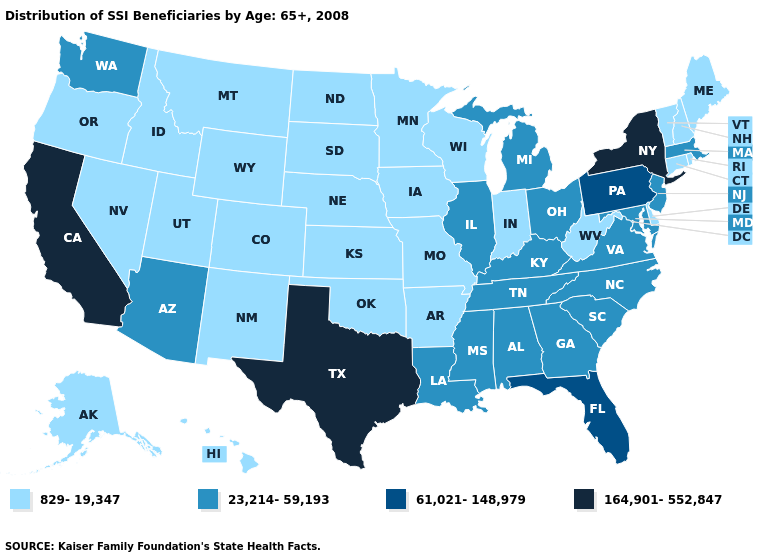What is the lowest value in the USA?
Write a very short answer. 829-19,347. Name the states that have a value in the range 23,214-59,193?
Answer briefly. Alabama, Arizona, Georgia, Illinois, Kentucky, Louisiana, Maryland, Massachusetts, Michigan, Mississippi, New Jersey, North Carolina, Ohio, South Carolina, Tennessee, Virginia, Washington. What is the value of Alabama?
Be succinct. 23,214-59,193. Does Kentucky have a higher value than Maryland?
Short answer required. No. Among the states that border New Jersey , does New York have the highest value?
Give a very brief answer. Yes. Which states have the lowest value in the MidWest?
Give a very brief answer. Indiana, Iowa, Kansas, Minnesota, Missouri, Nebraska, North Dakota, South Dakota, Wisconsin. Name the states that have a value in the range 829-19,347?
Short answer required. Alaska, Arkansas, Colorado, Connecticut, Delaware, Hawaii, Idaho, Indiana, Iowa, Kansas, Maine, Minnesota, Missouri, Montana, Nebraska, Nevada, New Hampshire, New Mexico, North Dakota, Oklahoma, Oregon, Rhode Island, South Dakota, Utah, Vermont, West Virginia, Wisconsin, Wyoming. What is the value of Wisconsin?
Keep it brief. 829-19,347. Does Nebraska have the lowest value in the MidWest?
Answer briefly. Yes. What is the value of Iowa?
Short answer required. 829-19,347. Among the states that border Alabama , which have the highest value?
Answer briefly. Florida. What is the lowest value in states that border New York?
Keep it brief. 829-19,347. What is the highest value in states that border Arkansas?
Concise answer only. 164,901-552,847. What is the value of Massachusetts?
Concise answer only. 23,214-59,193. What is the highest value in the South ?
Give a very brief answer. 164,901-552,847. 